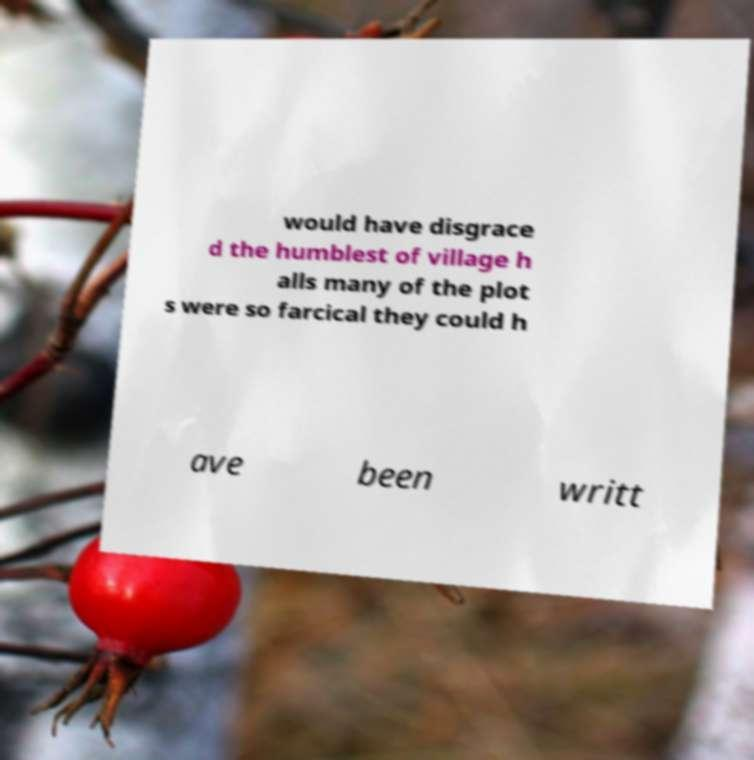For documentation purposes, I need the text within this image transcribed. Could you provide that? would have disgrace d the humblest of village h alls many of the plot s were so farcical they could h ave been writt 